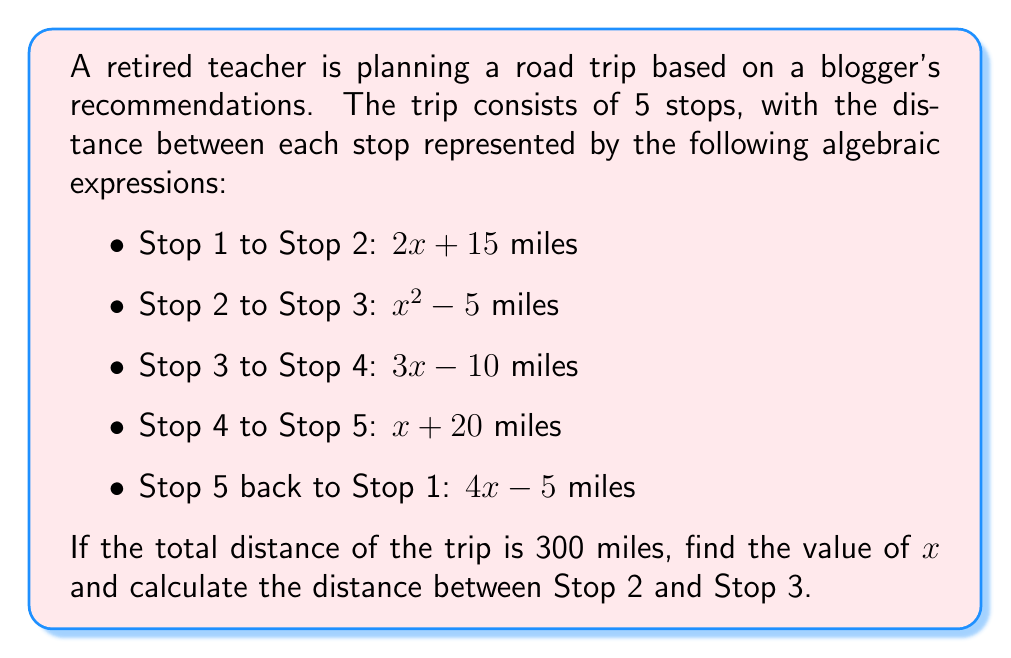Can you answer this question? Let's approach this step-by-step:

1) First, we need to set up an equation for the total distance:
   $$(2x + 15) + (x^2 - 5) + (3x - 10) + (x + 20) + (4x - 5) = 300$$

2) Simplify the left side of the equation:
   $$x^2 + 10x + 15 = 300$$

3) Rearrange the equation to standard form:
   $$x^2 + 10x - 285 = 0$$

4) This is a quadratic equation. We can solve it using the quadratic formula:
   $$x = \frac{-b \pm \sqrt{b^2 - 4ac}}{2a}$$
   where $a = 1$, $b = 10$, and $c = -285$

5) Plugging in these values:
   $$x = \frac{-10 \pm \sqrt{10^2 - 4(1)(-285)}}{2(1)}$$
   $$= \frac{-10 \pm \sqrt{100 + 1140}}{2}$$
   $$= \frac{-10 \pm \sqrt{1240}}{2}$$
   $$= \frac{-10 \pm 35.21}{2}$$

6) This gives us two solutions:
   $$x = \frac{-10 + 35.21}{2} = 12.61$$ or $$x = \frac{-10 - 35.21}{2} = -22.61$$

7) Since distance can't be negative, we take the positive solution: $x = 12.61$

8) Now, to find the distance between Stop 2 and Stop 3, we use the expression $x^2 - 5$:
   $$(12.61)^2 - 5 = 158.81 - 5 = 153.81$$

Therefore, the distance between Stop 2 and Stop 3 is approximately 153.81 miles.
Answer: 153.81 miles 